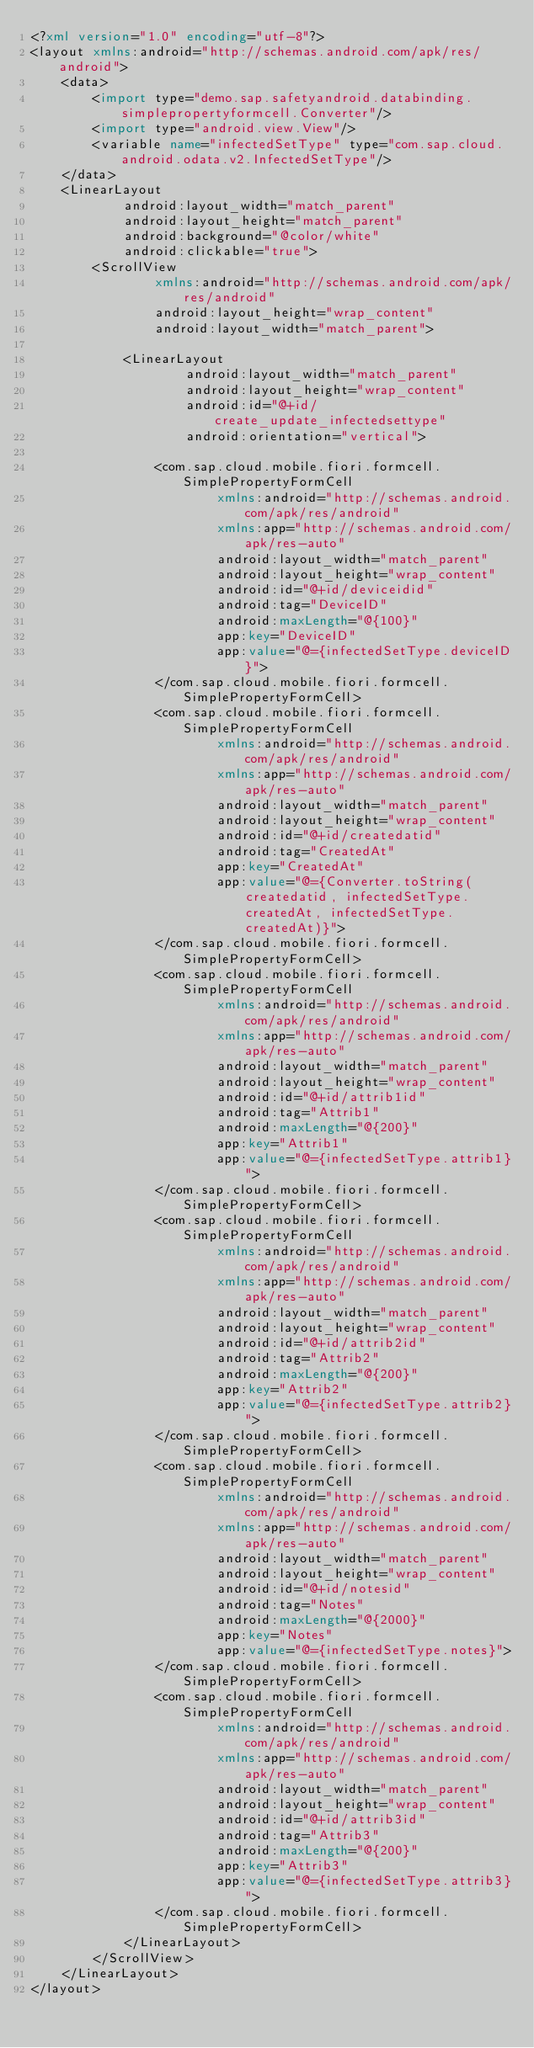<code> <loc_0><loc_0><loc_500><loc_500><_XML_><?xml version="1.0" encoding="utf-8"?>
<layout xmlns:android="http://schemas.android.com/apk/res/android">
    <data>
        <import type="demo.sap.safetyandroid.databinding.simplepropertyformcell.Converter"/>
        <import type="android.view.View"/>
        <variable name="infectedSetType" type="com.sap.cloud.android.odata.v2.InfectedSetType"/>
    </data>
    <LinearLayout
            android:layout_width="match_parent"
            android:layout_height="match_parent"
            android:background="@color/white"
            android:clickable="true">
        <ScrollView
                xmlns:android="http://schemas.android.com/apk/res/android"
                android:layout_height="wrap_content"
                android:layout_width="match_parent">

            <LinearLayout
                    android:layout_width="match_parent"
                    android:layout_height="wrap_content"
                    android:id="@+id/create_update_infectedsettype"
                    android:orientation="vertical">

                <com.sap.cloud.mobile.fiori.formcell.SimplePropertyFormCell
                        xmlns:android="http://schemas.android.com/apk/res/android"
                        xmlns:app="http://schemas.android.com/apk/res-auto"
                        android:layout_width="match_parent"
                        android:layout_height="wrap_content"
                        android:id="@+id/deviceidid"
                        android:tag="DeviceID"
                        android:maxLength="@{100}"
                        app:key="DeviceID"
                        app:value="@={infectedSetType.deviceID}">
                </com.sap.cloud.mobile.fiori.formcell.SimplePropertyFormCell>
                <com.sap.cloud.mobile.fiori.formcell.SimplePropertyFormCell
                        xmlns:android="http://schemas.android.com/apk/res/android"
                        xmlns:app="http://schemas.android.com/apk/res-auto"
                        android:layout_width="match_parent"
                        android:layout_height="wrap_content"
                        android:id="@+id/createdatid"
                        android:tag="CreatedAt"
                        app:key="CreatedAt"
                        app:value="@={Converter.toString(createdatid, infectedSetType.createdAt, infectedSetType.createdAt)}">
                </com.sap.cloud.mobile.fiori.formcell.SimplePropertyFormCell>
                <com.sap.cloud.mobile.fiori.formcell.SimplePropertyFormCell
                        xmlns:android="http://schemas.android.com/apk/res/android"
                        xmlns:app="http://schemas.android.com/apk/res-auto"
                        android:layout_width="match_parent"
                        android:layout_height="wrap_content"
                        android:id="@+id/attrib1id"
                        android:tag="Attrib1"
                        android:maxLength="@{200}"
                        app:key="Attrib1"
                        app:value="@={infectedSetType.attrib1}">
                </com.sap.cloud.mobile.fiori.formcell.SimplePropertyFormCell>
                <com.sap.cloud.mobile.fiori.formcell.SimplePropertyFormCell
                        xmlns:android="http://schemas.android.com/apk/res/android"
                        xmlns:app="http://schemas.android.com/apk/res-auto"
                        android:layout_width="match_parent"
                        android:layout_height="wrap_content"
                        android:id="@+id/attrib2id"
                        android:tag="Attrib2"
                        android:maxLength="@{200}"
                        app:key="Attrib2"
                        app:value="@={infectedSetType.attrib2}">
                </com.sap.cloud.mobile.fiori.formcell.SimplePropertyFormCell>
                <com.sap.cloud.mobile.fiori.formcell.SimplePropertyFormCell
                        xmlns:android="http://schemas.android.com/apk/res/android"
                        xmlns:app="http://schemas.android.com/apk/res-auto"
                        android:layout_width="match_parent"
                        android:layout_height="wrap_content"
                        android:id="@+id/notesid"
                        android:tag="Notes"
                        android:maxLength="@{2000}"
                        app:key="Notes"
                        app:value="@={infectedSetType.notes}">
                </com.sap.cloud.mobile.fiori.formcell.SimplePropertyFormCell>
                <com.sap.cloud.mobile.fiori.formcell.SimplePropertyFormCell
                        xmlns:android="http://schemas.android.com/apk/res/android"
                        xmlns:app="http://schemas.android.com/apk/res-auto"
                        android:layout_width="match_parent"
                        android:layout_height="wrap_content"
                        android:id="@+id/attrib3id"
                        android:tag="Attrib3"
                        android:maxLength="@{200}"
                        app:key="Attrib3"
                        app:value="@={infectedSetType.attrib3}">
                </com.sap.cloud.mobile.fiori.formcell.SimplePropertyFormCell>
            </LinearLayout>
        </ScrollView>
    </LinearLayout>
</layout></code> 